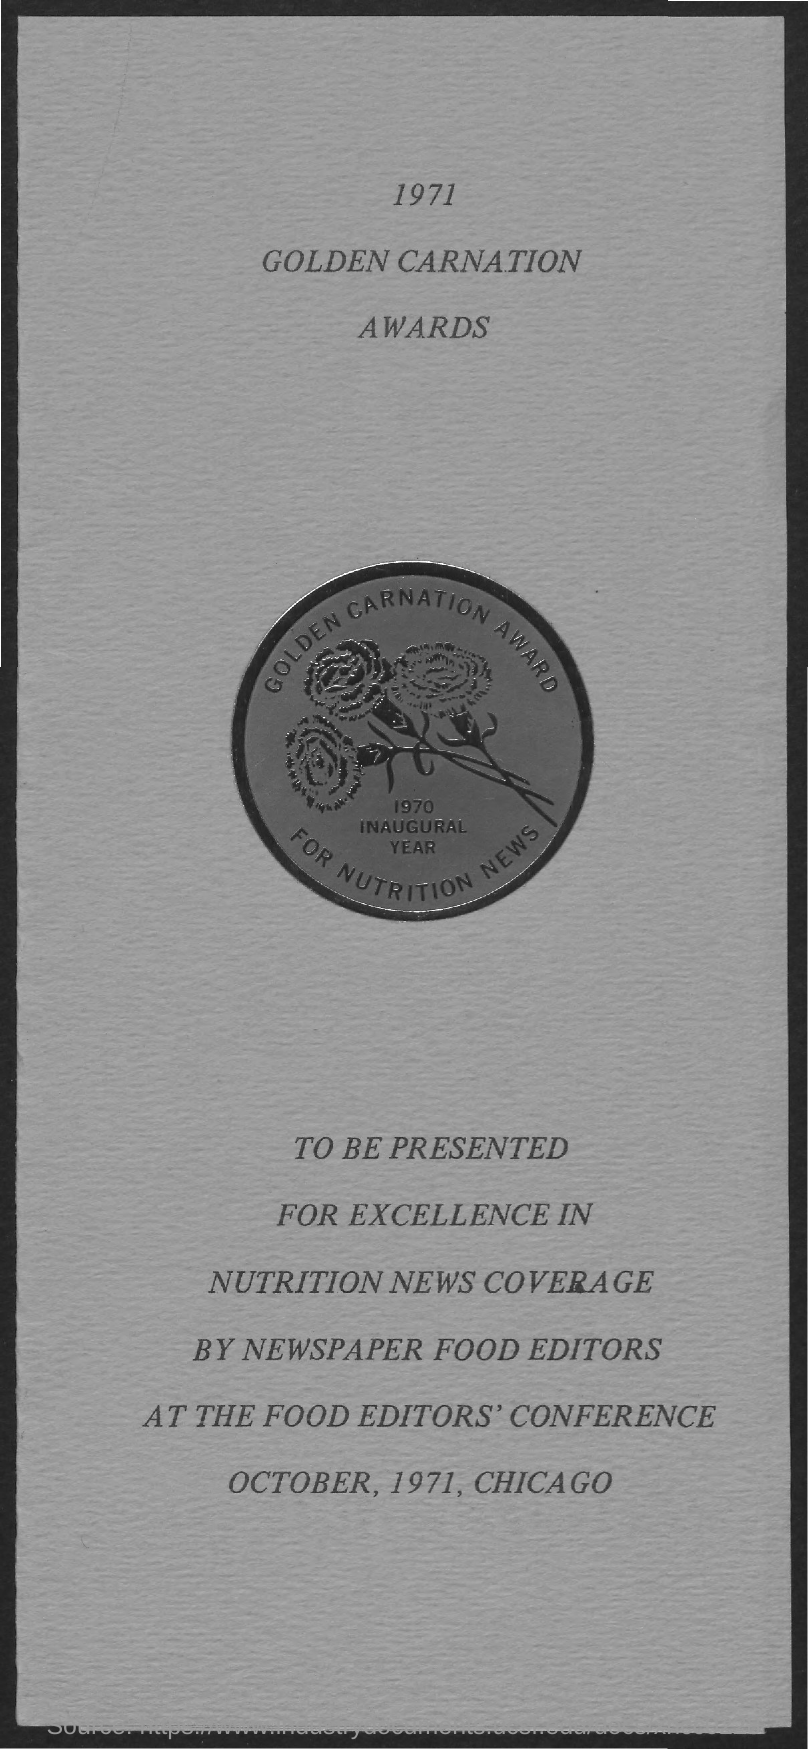When is it presented?
Your answer should be compact. October, 1971. 